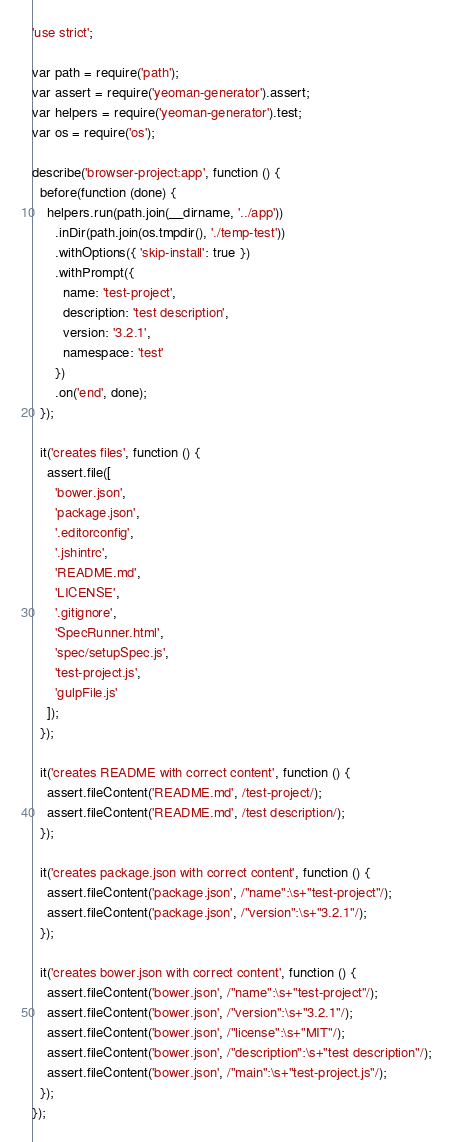<code> <loc_0><loc_0><loc_500><loc_500><_JavaScript_>'use strict';

var path = require('path');
var assert = require('yeoman-generator').assert;
var helpers = require('yeoman-generator').test;
var os = require('os');

describe('browser-project:app', function () {
  before(function (done) {
    helpers.run(path.join(__dirname, '../app'))
      .inDir(path.join(os.tmpdir(), './temp-test'))
      .withOptions({ 'skip-install': true })
      .withPrompt({
        name: 'test-project',
        description: 'test description',
        version: '3.2.1',
        namespace: 'test'
      })
      .on('end', done);
  });

  it('creates files', function () {
    assert.file([
      'bower.json',
      'package.json',
      '.editorconfig',
      '.jshintrc',
      'README.md',
      'LICENSE',
      '.gitignore',
      'SpecRunner.html',
      'spec/setupSpec.js',
      'test-project.js',
      'gulpFile.js'
    ]);
  });

  it('creates README with correct content', function () {
    assert.fileContent('README.md', /test-project/);
    assert.fileContent('README.md', /test description/);
  });

  it('creates package.json with correct content', function () {
    assert.fileContent('package.json', /"name":\s+"test-project"/);
    assert.fileContent('package.json', /"version":\s+"3.2.1"/);
  });

  it('creates bower.json with correct content', function () {
    assert.fileContent('bower.json', /"name":\s+"test-project"/);
    assert.fileContent('bower.json', /"version":\s+"3.2.1"/);
    assert.fileContent('bower.json', /"license":\s+"MIT"/);
    assert.fileContent('bower.json', /"description":\s+"test description"/);
    assert.fileContent('bower.json', /"main":\s+"test-project.js"/);
  });
});
</code> 